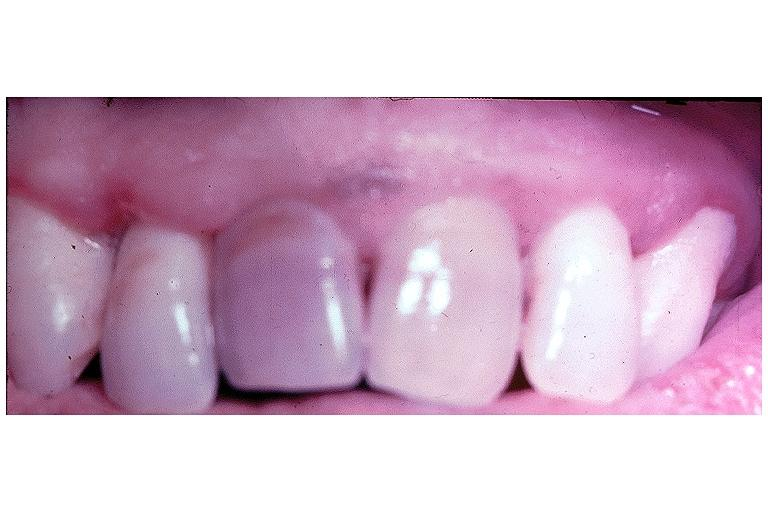what does this image show?
Answer the question using a single word or phrase. Pulpal necrosis 